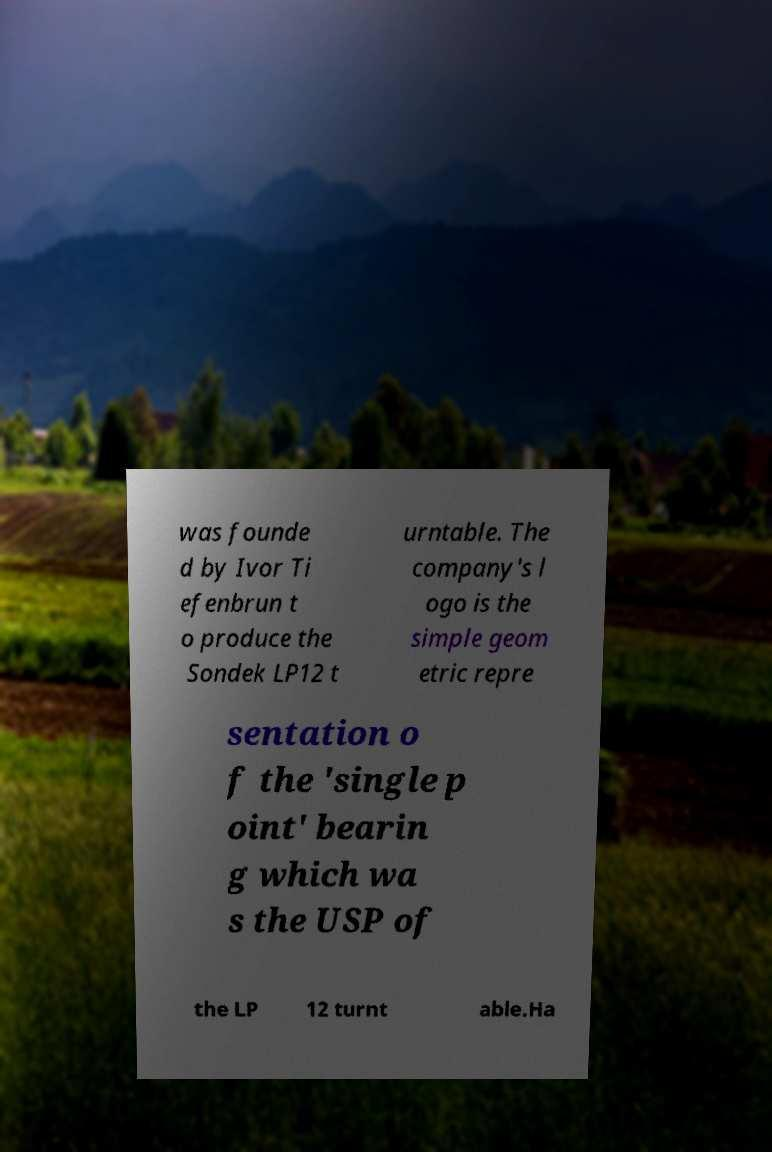I need the written content from this picture converted into text. Can you do that? was founde d by Ivor Ti efenbrun t o produce the Sondek LP12 t urntable. The company's l ogo is the simple geom etric repre sentation o f the 'single p oint' bearin g which wa s the USP of the LP 12 turnt able.Ha 